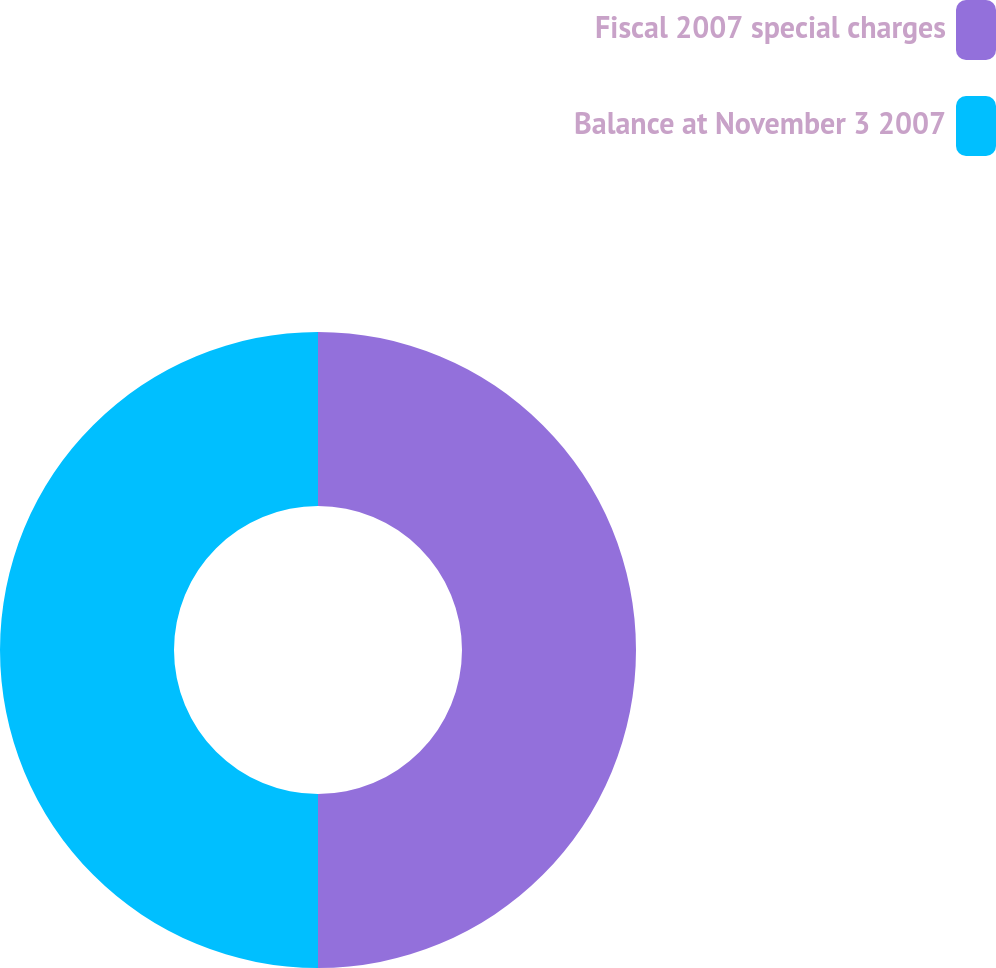Convert chart to OTSL. <chart><loc_0><loc_0><loc_500><loc_500><pie_chart><fcel>Fiscal 2007 special charges<fcel>Balance at November 3 2007<nl><fcel>50.0%<fcel>50.0%<nl></chart> 